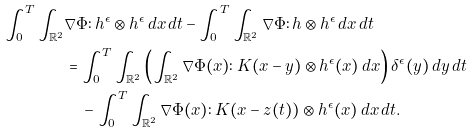<formula> <loc_0><loc_0><loc_500><loc_500>\int _ { 0 } ^ { T } \int _ { \mathbb { R } ^ { 2 } } & \nabla \Phi \colon h ^ { \epsilon } \otimes h ^ { \epsilon } \, d x \, d t - \int _ { 0 } ^ { T } \int _ { \mathbb { R } ^ { 2 } } \nabla \Phi \colon h \otimes h ^ { \epsilon } \, d x \, d t \\ & = \int _ { 0 } ^ { T } \int _ { \mathbb { R } ^ { 2 } } \left ( \int _ { \mathbb { R } ^ { 2 } } \nabla \Phi ( x ) \colon K ( x - y ) \otimes h ^ { \epsilon } ( x ) \, d x \right ) \delta ^ { \epsilon } ( y ) \, d y \, d t \\ & \quad - \int _ { 0 } ^ { T } \int _ { \mathbb { R } ^ { 2 } } \nabla \Phi ( x ) \colon K ( x - z ( t ) ) \otimes h ^ { \epsilon } ( x ) \, d x \, d t .</formula> 